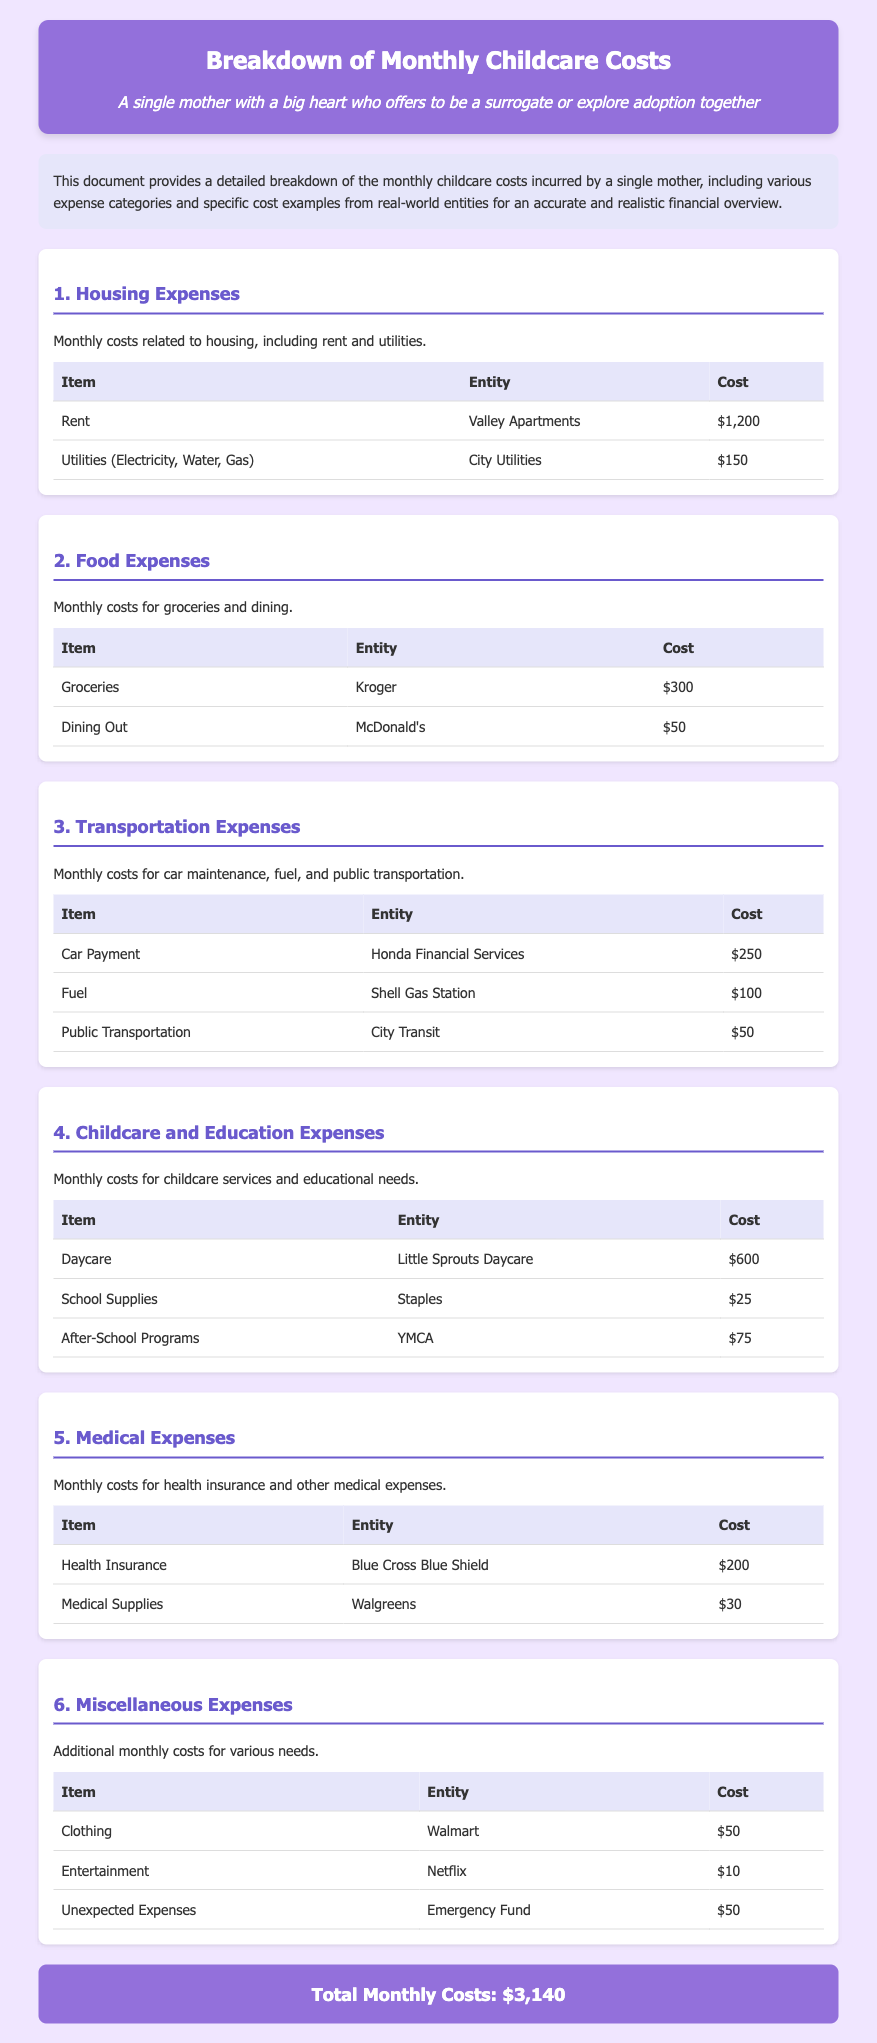what is the total monthly cost? The total monthly cost is the sum of all listed expenses in the document, which is calculated as $3,140.
Answer: $3,140 how much does rent cost? The cost of rent is listed as $1,200 in the document.
Answer: $1,200 what is the cost of groceries? The cost of groceries is specified as $300 in the document.
Answer: $300 how much is spent on daycare? The daycare expense is reported as $600 in the document.
Answer: $600 what is the cost of transportation fuel? The cost of fuel for transportation is detailed as $100 in the document.
Answer: $100 what are the medical supplies costs? Medical supplies are listed at $30 in the document.
Answer: $30 how much is spent on unexpected expenses? The unexpected expenses are outlined as $50 in the document.
Answer: $50 which entity provides health insurance? The health insurance provider mentioned is Blue Cross Blue Shield in the document.
Answer: Blue Cross Blue Shield what is the cost associated with after-school programs? The after-school programs expense is indicated as $75 in the document.
Answer: $75 